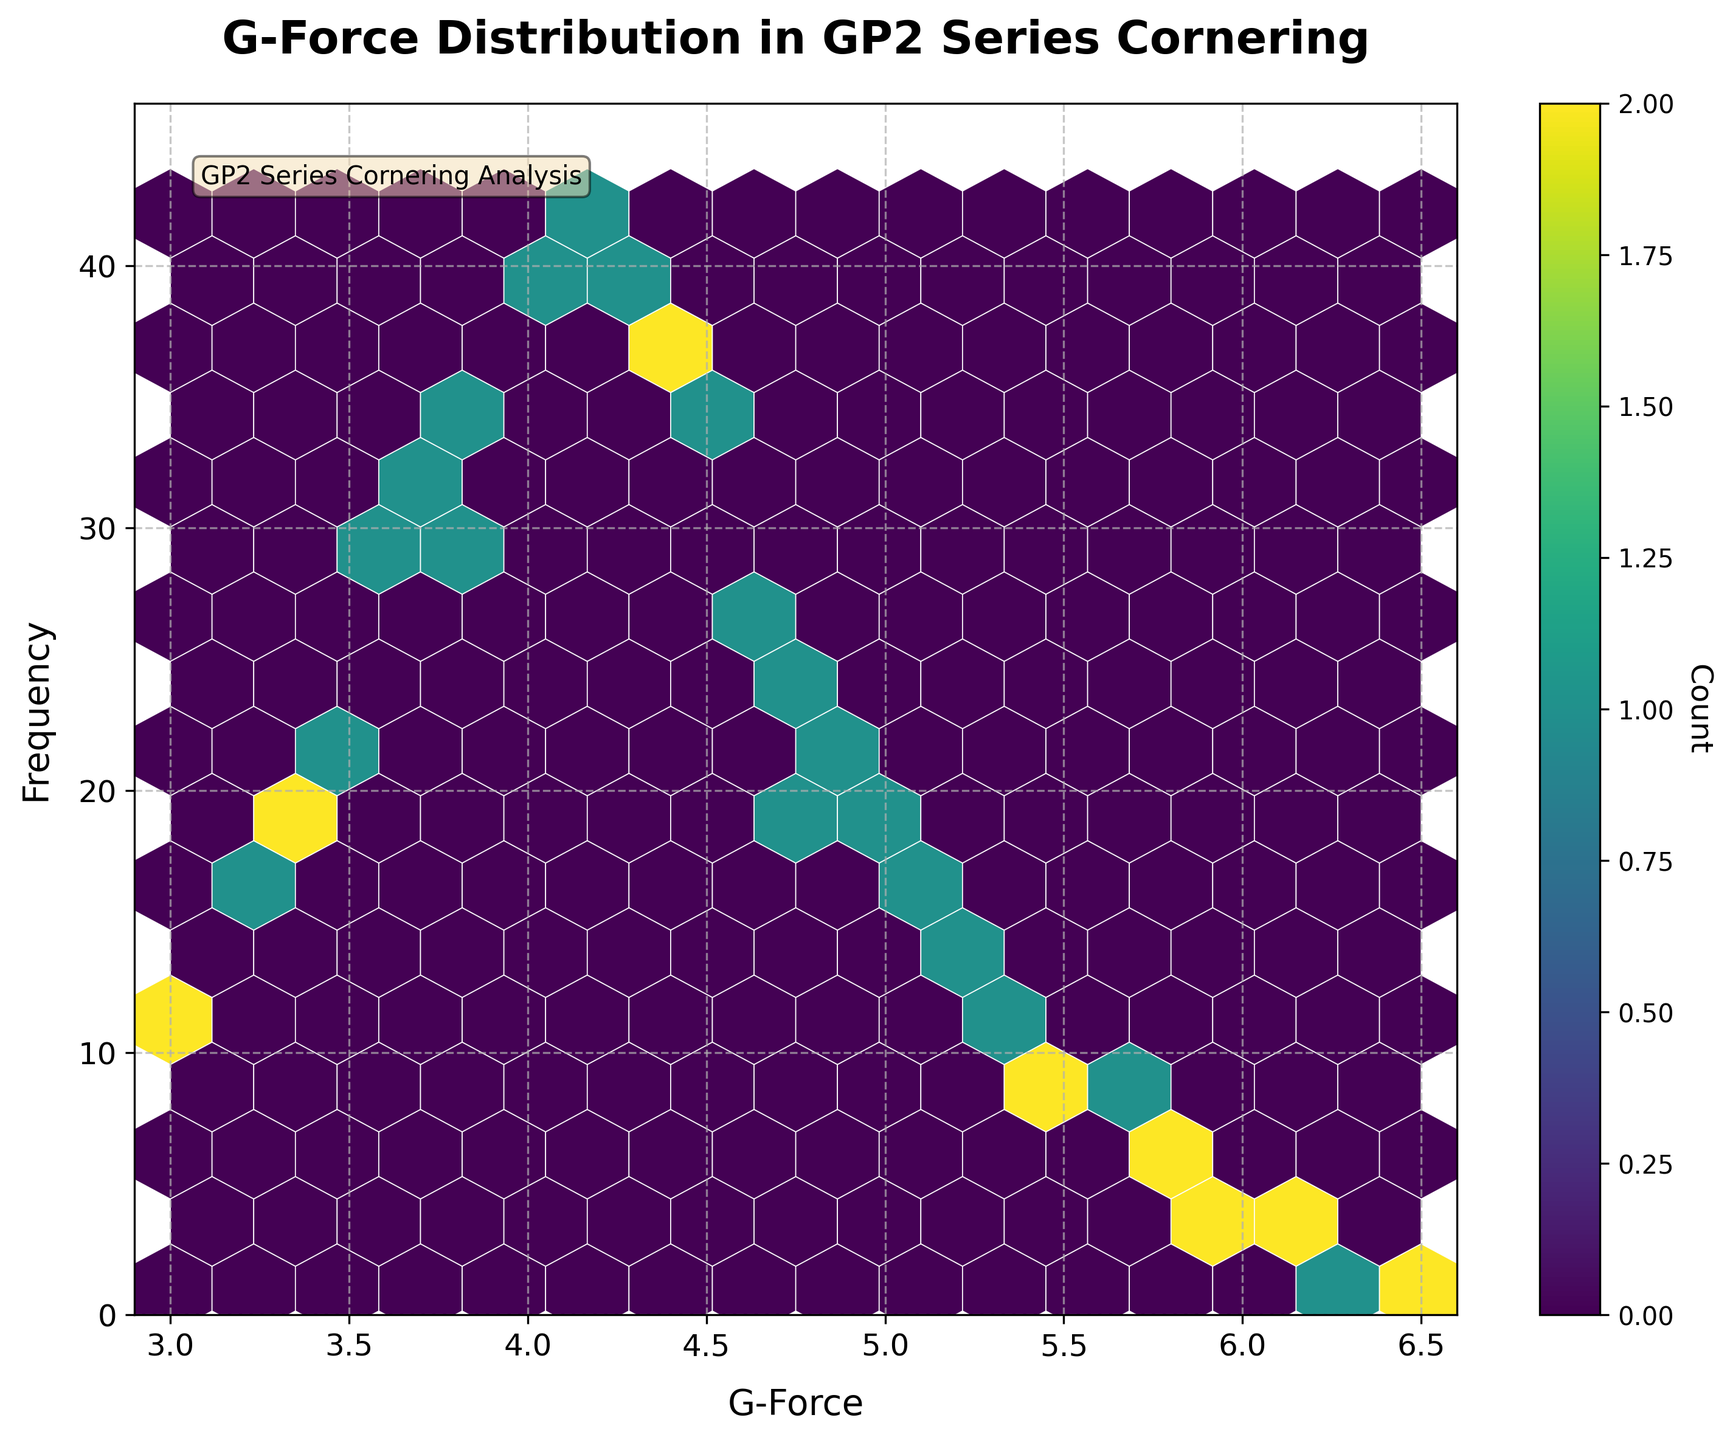What is the title of the plot? To find the title, look at the top center of the plot where the title is usually placed. Here, it states "G-Force Distribution in GP2 Series Cornering".
Answer: G-Force Distribution in GP2 Series Cornering What are the labels for the x and y axes? Labels for the axes are typically found along the horizontal and vertical axes; here they are "G-Force" for the x-axis and "Frequency" for the y-axis.
Answer: G-Force, Frequency What color map is used in the hexbin plot? The color map used in the hexbin plot can be inferred from the gradient provided in the color bar, which is "viridis," transitioning from dark purple to yellow.
Answer: viridis Which G-force value has the highest frequency count? To determine this, look for the highest density (brightest) hexagon in the plot; then read the corresponding G-force value along the x-axis. The brightest hexagons are around the G-force of 4.1, with a peak in frequency.
Answer: 4.1 What is the range of G-Force values displayed on the x-axis? To find the range, look at the axis ticks and limits on the x-axis. The plot shows G-force values from 2.9 to 6.6.
Answer: 2.9 to 6.6 Approximately how much higher is the frequency at G-force 4.1 compared to G-force 5.3? To compare, note the frequency corresponding to these G-force values from the plot. At G-force 4.1, the count is around 42, and at G-force 5.3, it's around 12. The difference is 42 - 12 = 30.
Answer: 30 What is the distribution shape of the frequency across different G-Force values? By observing the distribution of color intensity across the plot, you can infer that the frequency distribution is unimodal with a peak frequency around a G-force of 4.1. The distribution tapers off on either side.
Answer: Unimodal How many hexagons represent a frequency (count) greater than 20? By visually counting the hexagons with a color intensity corresponding to a frequency greater than 20, you can see around 5 hexagons with frequencies above this threshold.
Answer: 5 